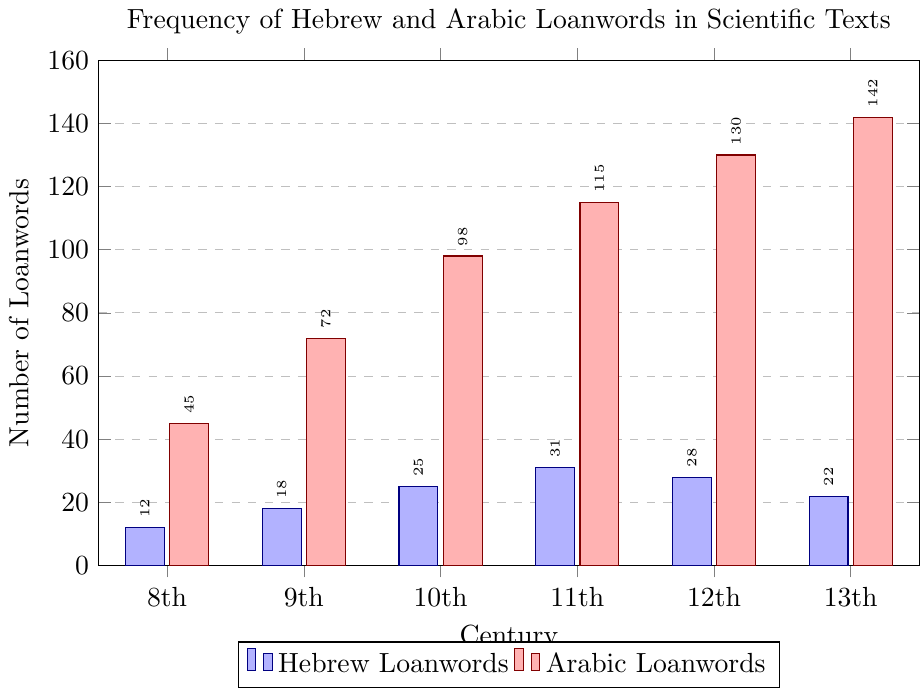Who loanwords increased more significantly from the 8th to the 13th century, Hebrew or Arabic? Compare the values for each type in the 8th and 13th centuries. Hebrew loanwords increased from 12 to 22 (an increase of 10), while Arabic loanwords increased from 45 to 142 (an increase of 97).
Answer: Arabic What is the total number of Hebrew and Arabic loanwords in texts by the 11th century? Sum the values for both Hebrew and Arabic loanwords up to the 11th century: Hebrew (12 + 18 + 25 + 31) + Arabic (45 + 72 + 98 + 115). The total is 86 for Hebrew and 330 for Arabic.
Answer: 416 In which century do the Hebrew loanwords reach their maximum frequency? Identify the highest bar for Hebrew loanwords, which occurs in the 11th century with 31 loanwords.
Answer: 11th century How many more Arabic loanwords than Hebrew loanwords are there in the 12th century? Subtract the number of Hebrew loanwords from the number of Arabic loanwords in the 12th century (130 - 28).
Answer: 102 Which century shows the largest percentage increase in Arabic loanwords from the previous century? Calculate the percentage increase for each century and compare: 
  9th: (72/45 - 1) * 100 ≈ 60%
  10th: (98/72 - 1) * 100 ≈ 36.1%
  11th: (115/98 - 1) * 100 ≈ 17.3%
  12th: (130/115 - 1) * 100 ≈ 13%
  13th: (142/130 - 1) * 100 ≈ 9.2%
The largest increase is from the 8th to the 9th century.
Answer: 9th century Which loanwords, Hebrew or Arabic, had a more constant rate of increase across the centuries? By visually comparing the heights of the bars, the Arabic loanwords display a more consistent and smoother increase across the centuries, whereas the Hebrew loanwords show more fluctuation.
Answer: Arabic In which century did the Hebrew loanwords decrease compared to the previous century? Compare the values of Hebrew loanwords for each century to find decreases: there is only a decrease from the 12th century (28) to the 13th century (22).
Answer: 13th century What is the average number of Arabic loanwords during the 9th to 12th centuries? Sum the values of Arabic loanwords for the 9th to 12th centuries and divide by the number of centuries (72 + 98 + 115 + 130)/4. The sum is 415, so the average is 415/4 = 103.75.
Answer: 103.75 